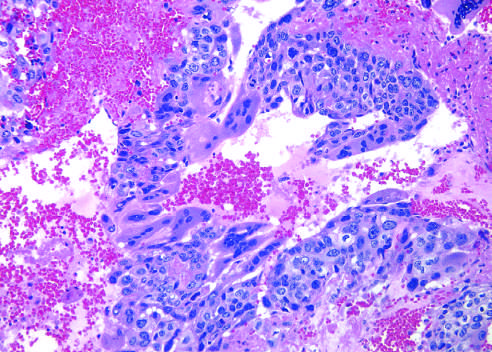re the pattern of staining of anti-centromere antibodies prominent?
Answer the question using a single word or phrase. No 